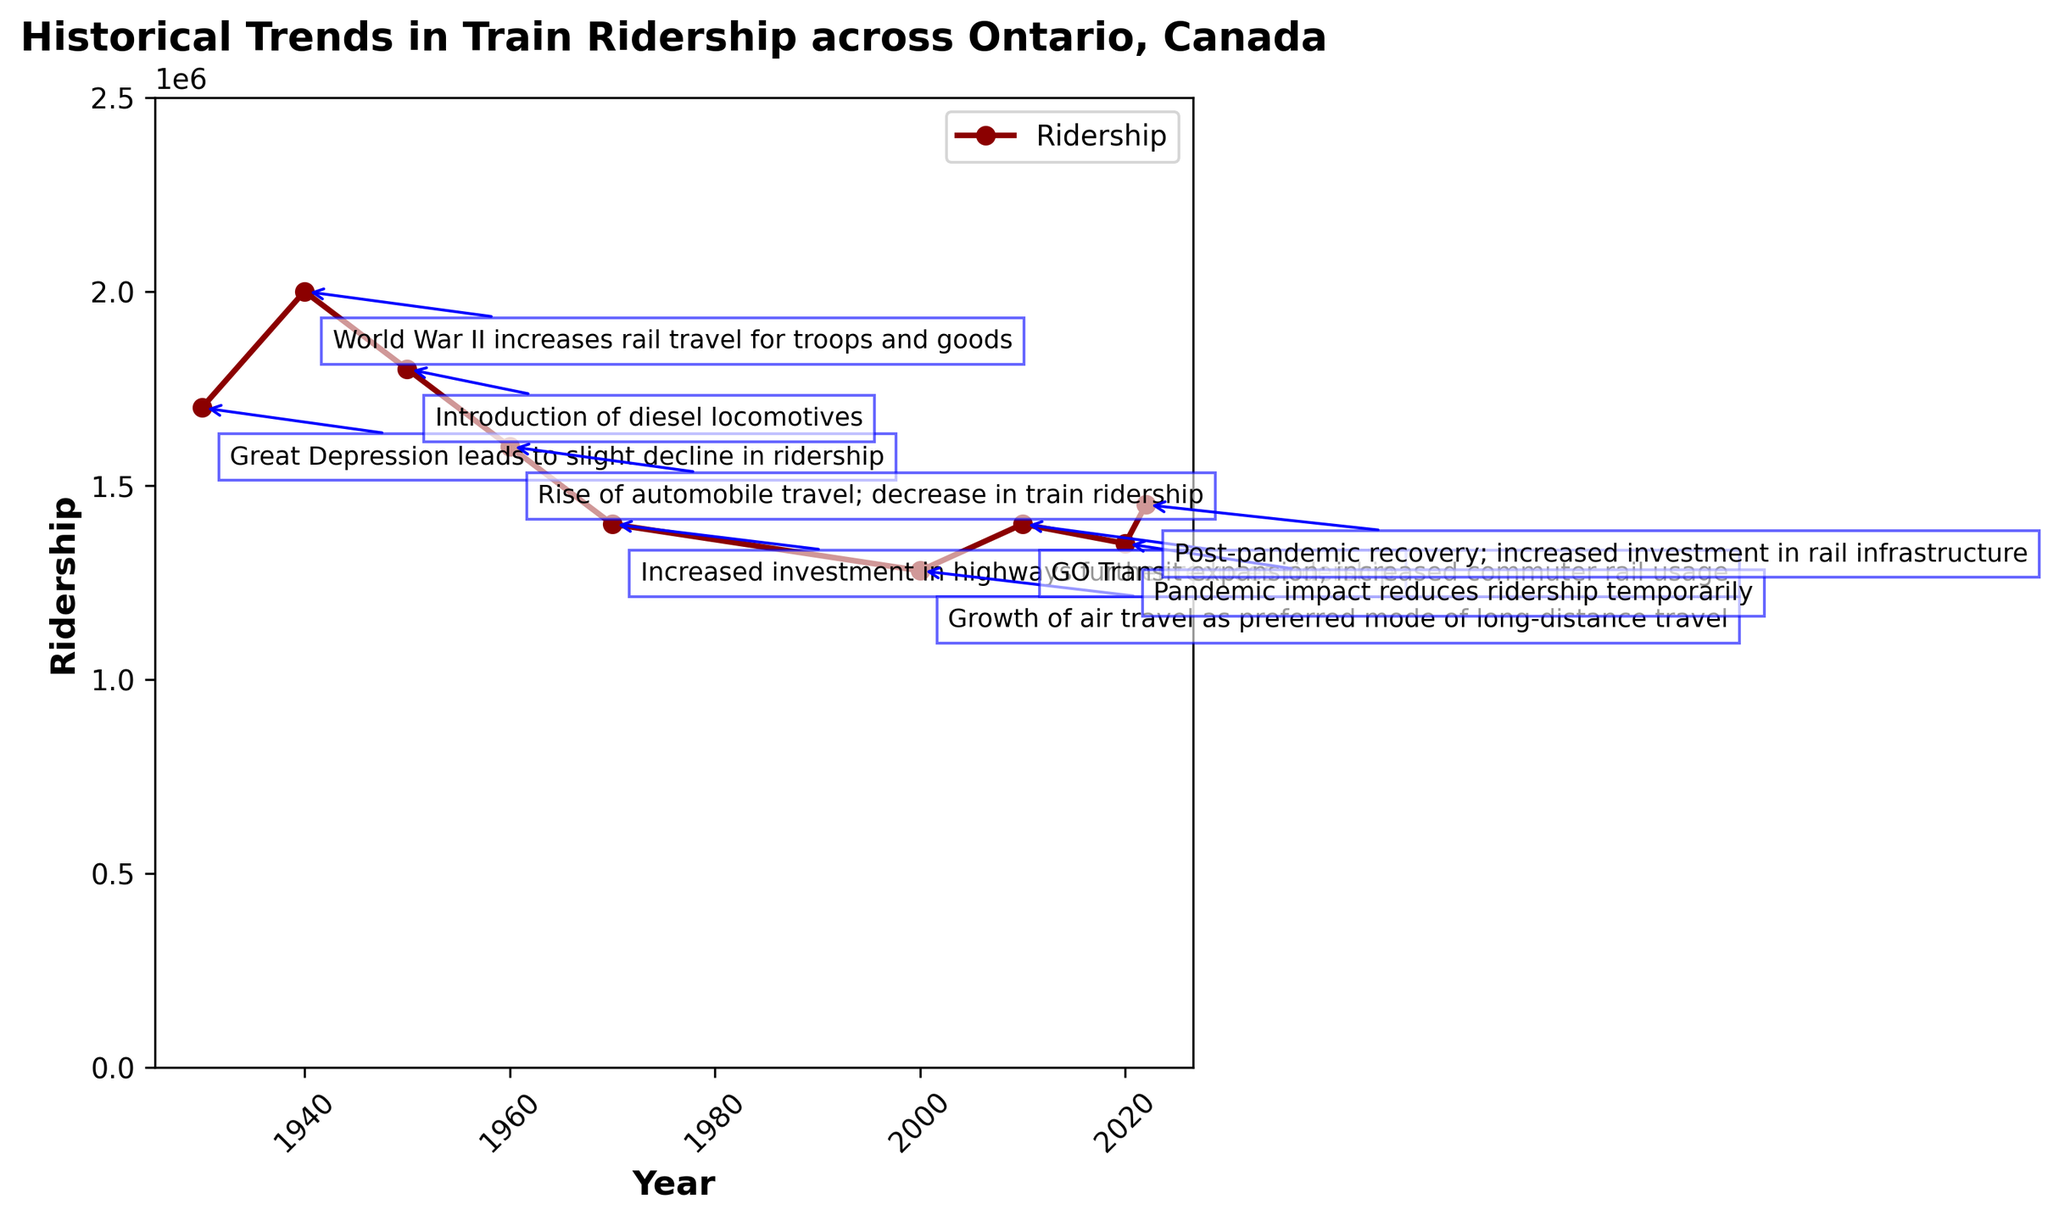what major event led to a temporary rise in ridership in the 2010s? The figure shows that ridership increased in the 2010s due to the "GO Transit expansion; increased commuter rail usage," indicating a rise in commuter rail services.
Answer: GO Transit expansion During which decade did the ridership see its highest peak? From the figure, the highest ridership peak is around the 1940s, marked by "World War II increases rail travel for troops and goods."
Answer: 1940s By how much did ridership decrease from 1950 to 1970? To find the decrease, subtract the 1970 ridership (1,400,000) from the 1950 ridership (1,800,000). The difference is 1,800,000 - 1,400,000 = 400,000.
Answer: 400,000 Which two events that led to a decrease in ridership occurred in consecutive decades? From the figure, the "Rise of automobile travel" in the 1960s and the "Increased investment in highways" in the 1970s both contributed to a decline in ridership in back-to-back decades.
Answer: Rise of automobile travel and Increased investment in highways What is the ridership change from the pandemic impact until the post-pandemic recovery? The pandemic impact in 2020 resulted in a ridership of 1,350,000, which increased to 1,450,000 by 2022 during the post-pandemic recovery. The change is 1,450,000 - 1,350,000 = 100,000.
Answer: 100,000 What is the average ridership for the years annotated in the figure? To find the average, sum all the ridership values: 1,700,000 + 2,000,000 + 1,800,000 + 1,600,000 + 1,400,000 + 1,280,000 + 1,400,000 + 1,350,000 + 1,450,000 = 13,980,000. There are 9 data points, so divide the sum by 9: 13,980,000 / 9 ≈ 1,553,333.
Answer: 1,553,333 Which mode of transportation rise is correlated with a major decrease in train ridership in the 1960s? The figure shows that the "Rise of automobile travel" in the 1960s correlates with the major decrease in train ridership during that decade.
Answer: automobile travel In which decade did the introduction of diesel locomotives occur, and did it result in a ridership increase or decrease? The figure indicates that diesel locomotives were introduced in the 1950s, coinciding with a slight decrease in ridership, from 2,000,000 in 1940 to 1,800,000 in 1950.
Answer: 1950s, decrease 